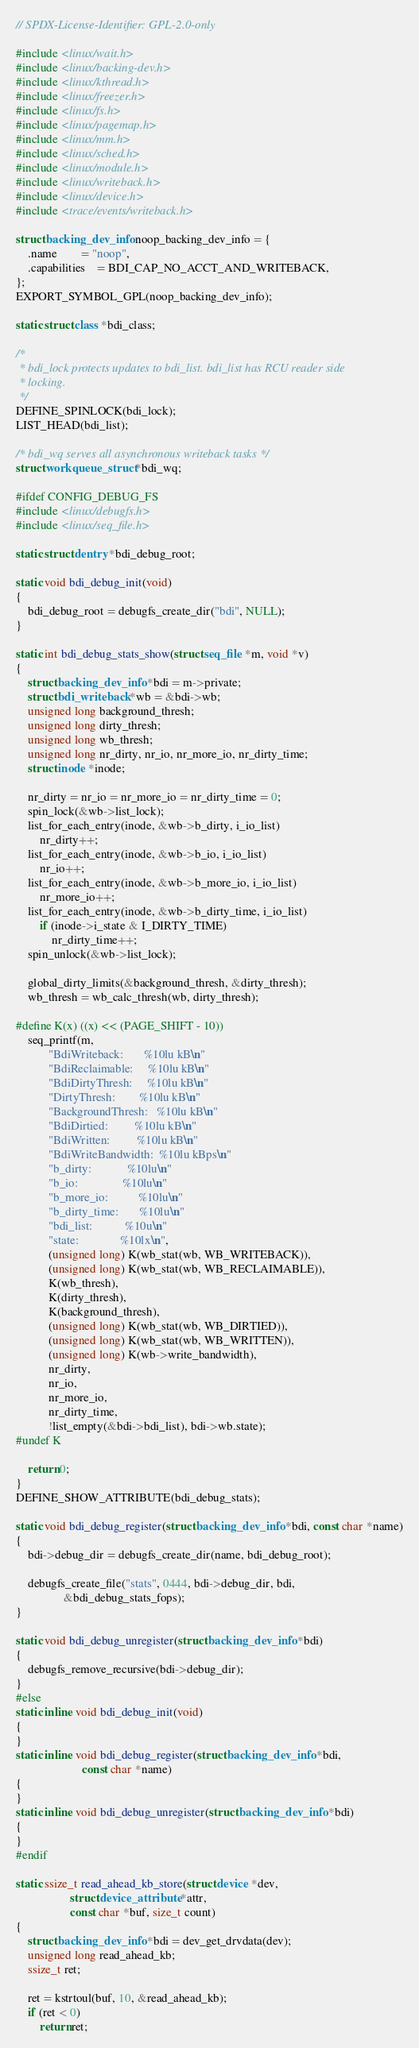Convert code to text. <code><loc_0><loc_0><loc_500><loc_500><_C_>// SPDX-License-Identifier: GPL-2.0-only

#include <linux/wait.h>
#include <linux/backing-dev.h>
#include <linux/kthread.h>
#include <linux/freezer.h>
#include <linux/fs.h>
#include <linux/pagemap.h>
#include <linux/mm.h>
#include <linux/sched.h>
#include <linux/module.h>
#include <linux/writeback.h>
#include <linux/device.h>
#include <trace/events/writeback.h>

struct backing_dev_info noop_backing_dev_info = {
	.name		= "noop",
	.capabilities	= BDI_CAP_NO_ACCT_AND_WRITEBACK,
};
EXPORT_SYMBOL_GPL(noop_backing_dev_info);

static struct class *bdi_class;

/*
 * bdi_lock protects updates to bdi_list. bdi_list has RCU reader side
 * locking.
 */
DEFINE_SPINLOCK(bdi_lock);
LIST_HEAD(bdi_list);

/* bdi_wq serves all asynchronous writeback tasks */
struct workqueue_struct *bdi_wq;

#ifdef CONFIG_DEBUG_FS
#include <linux/debugfs.h>
#include <linux/seq_file.h>

static struct dentry *bdi_debug_root;

static void bdi_debug_init(void)
{
	bdi_debug_root = debugfs_create_dir("bdi", NULL);
}

static int bdi_debug_stats_show(struct seq_file *m, void *v)
{
	struct backing_dev_info *bdi = m->private;
	struct bdi_writeback *wb = &bdi->wb;
	unsigned long background_thresh;
	unsigned long dirty_thresh;
	unsigned long wb_thresh;
	unsigned long nr_dirty, nr_io, nr_more_io, nr_dirty_time;
	struct inode *inode;

	nr_dirty = nr_io = nr_more_io = nr_dirty_time = 0;
	spin_lock(&wb->list_lock);
	list_for_each_entry(inode, &wb->b_dirty, i_io_list)
		nr_dirty++;
	list_for_each_entry(inode, &wb->b_io, i_io_list)
		nr_io++;
	list_for_each_entry(inode, &wb->b_more_io, i_io_list)
		nr_more_io++;
	list_for_each_entry(inode, &wb->b_dirty_time, i_io_list)
		if (inode->i_state & I_DIRTY_TIME)
			nr_dirty_time++;
	spin_unlock(&wb->list_lock);

	global_dirty_limits(&background_thresh, &dirty_thresh);
	wb_thresh = wb_calc_thresh(wb, dirty_thresh);

#define K(x) ((x) << (PAGE_SHIFT - 10))
	seq_printf(m,
		   "BdiWriteback:       %10lu kB\n"
		   "BdiReclaimable:     %10lu kB\n"
		   "BdiDirtyThresh:     %10lu kB\n"
		   "DirtyThresh:        %10lu kB\n"
		   "BackgroundThresh:   %10lu kB\n"
		   "BdiDirtied:         %10lu kB\n"
		   "BdiWritten:         %10lu kB\n"
		   "BdiWriteBandwidth:  %10lu kBps\n"
		   "b_dirty:            %10lu\n"
		   "b_io:               %10lu\n"
		   "b_more_io:          %10lu\n"
		   "b_dirty_time:       %10lu\n"
		   "bdi_list:           %10u\n"
		   "state:              %10lx\n",
		   (unsigned long) K(wb_stat(wb, WB_WRITEBACK)),
		   (unsigned long) K(wb_stat(wb, WB_RECLAIMABLE)),
		   K(wb_thresh),
		   K(dirty_thresh),
		   K(background_thresh),
		   (unsigned long) K(wb_stat(wb, WB_DIRTIED)),
		   (unsigned long) K(wb_stat(wb, WB_WRITTEN)),
		   (unsigned long) K(wb->write_bandwidth),
		   nr_dirty,
		   nr_io,
		   nr_more_io,
		   nr_dirty_time,
		   !list_empty(&bdi->bdi_list), bdi->wb.state);
#undef K

	return 0;
}
DEFINE_SHOW_ATTRIBUTE(bdi_debug_stats);

static void bdi_debug_register(struct backing_dev_info *bdi, const char *name)
{
	bdi->debug_dir = debugfs_create_dir(name, bdi_debug_root);

	debugfs_create_file("stats", 0444, bdi->debug_dir, bdi,
			    &bdi_debug_stats_fops);
}

static void bdi_debug_unregister(struct backing_dev_info *bdi)
{
	debugfs_remove_recursive(bdi->debug_dir);
}
#else
static inline void bdi_debug_init(void)
{
}
static inline void bdi_debug_register(struct backing_dev_info *bdi,
				      const char *name)
{
}
static inline void bdi_debug_unregister(struct backing_dev_info *bdi)
{
}
#endif

static ssize_t read_ahead_kb_store(struct device *dev,
				  struct device_attribute *attr,
				  const char *buf, size_t count)
{
	struct backing_dev_info *bdi = dev_get_drvdata(dev);
	unsigned long read_ahead_kb;
	ssize_t ret;

	ret = kstrtoul(buf, 10, &read_ahead_kb);
	if (ret < 0)
		return ret;
</code> 